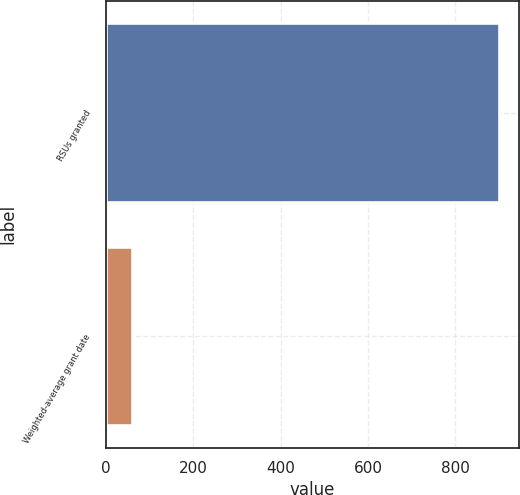Convert chart to OTSL. <chart><loc_0><loc_0><loc_500><loc_500><bar_chart><fcel>RSUs granted<fcel>Weighted-average grant date<nl><fcel>901<fcel>60.55<nl></chart> 